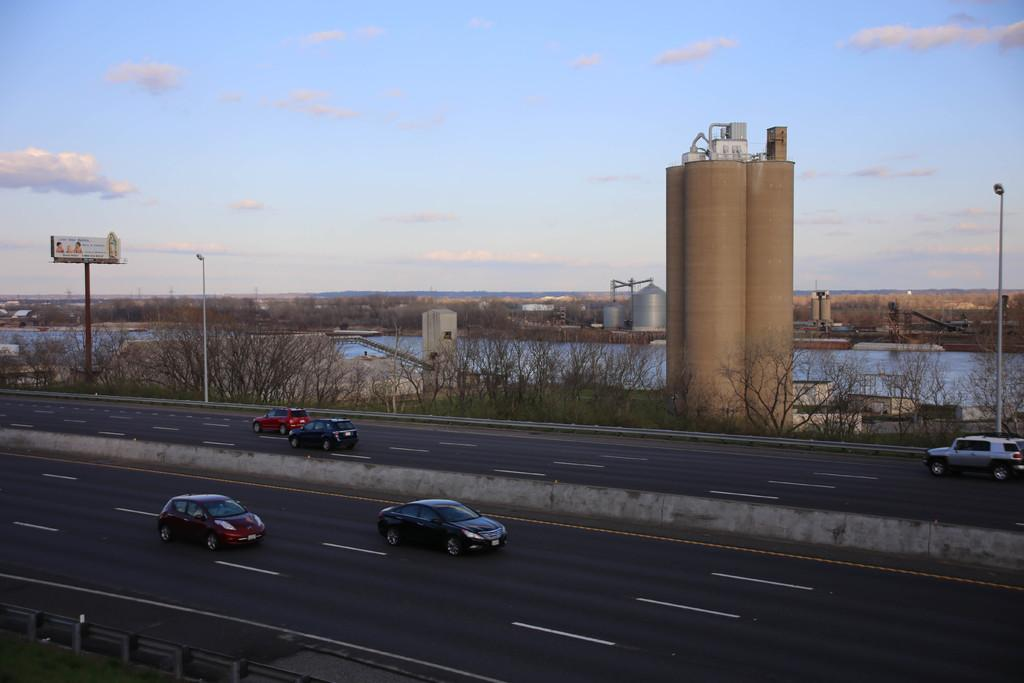What can be seen on the roads in the image? There are vehicles on the roads in the image. What type of vegetation is present in the image? There are trees and grass in the image. What structures can be seen in the image? There are silos, poles, a hoarding, and lights in the image. What natural element is visible in the image? Water is visible in the image. What is visible in the background of the image? The sky is visible in the background of the image. Can you tell me how many yaks are grazing in the grass in the image? There are no yaks present in the image; it features vehicles on the roads, trees, silos, poles, a hoarding, lights, grass, water, and the sky in the background. What type of joke is being told by the trees in the image? There is no joke being told in the image; it is a still image featuring various objects and elements. 